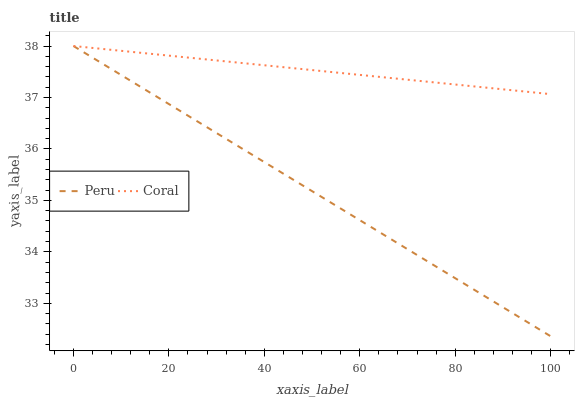Does Peru have the minimum area under the curve?
Answer yes or no. Yes. Does Coral have the maximum area under the curve?
Answer yes or no. Yes. Does Peru have the maximum area under the curve?
Answer yes or no. No. Is Coral the smoothest?
Answer yes or no. Yes. Is Peru the roughest?
Answer yes or no. Yes. Is Peru the smoothest?
Answer yes or no. No. Does Peru have the lowest value?
Answer yes or no. Yes. Does Peru have the highest value?
Answer yes or no. Yes. Does Peru intersect Coral?
Answer yes or no. Yes. Is Peru less than Coral?
Answer yes or no. No. Is Peru greater than Coral?
Answer yes or no. No. 